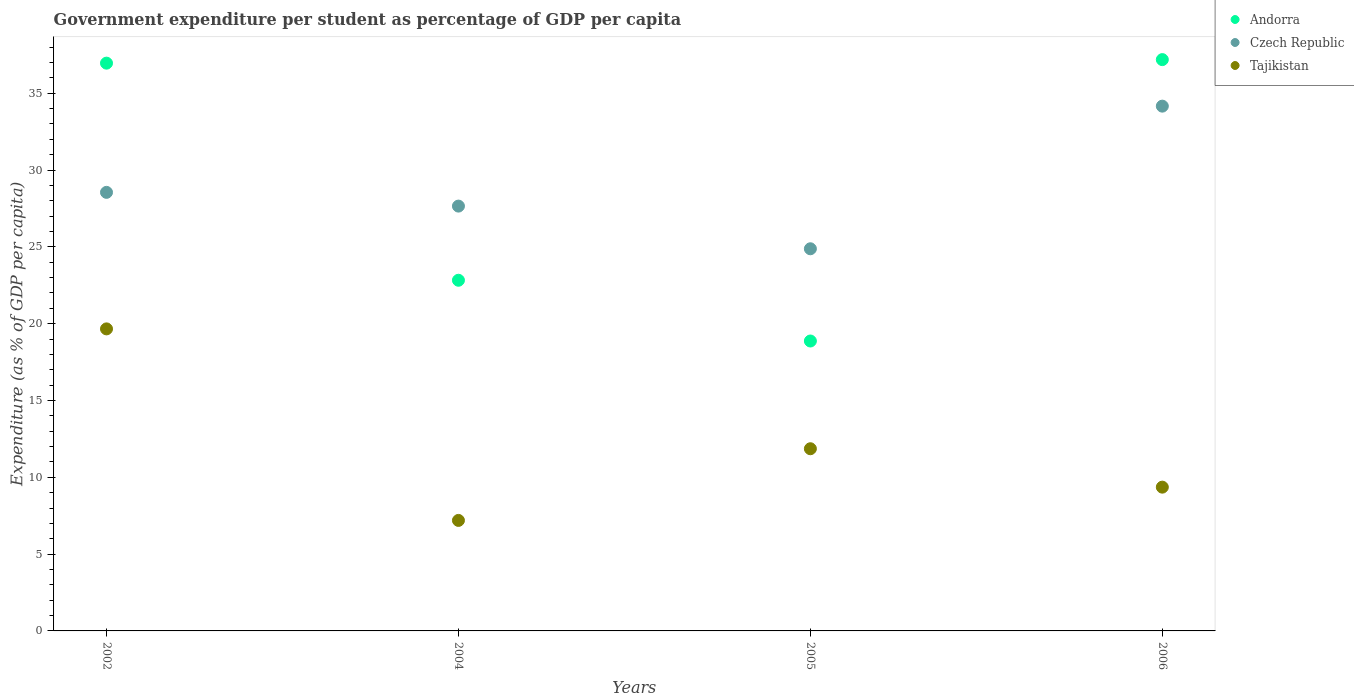How many different coloured dotlines are there?
Keep it short and to the point. 3. Is the number of dotlines equal to the number of legend labels?
Keep it short and to the point. Yes. What is the percentage of expenditure per student in Tajikistan in 2002?
Your answer should be compact. 19.66. Across all years, what is the maximum percentage of expenditure per student in Andorra?
Make the answer very short. 37.19. Across all years, what is the minimum percentage of expenditure per student in Andorra?
Your answer should be very brief. 18.87. In which year was the percentage of expenditure per student in Tajikistan maximum?
Offer a terse response. 2002. What is the total percentage of expenditure per student in Czech Republic in the graph?
Keep it short and to the point. 115.23. What is the difference between the percentage of expenditure per student in Czech Republic in 2002 and that in 2004?
Make the answer very short. 0.89. What is the difference between the percentage of expenditure per student in Czech Republic in 2006 and the percentage of expenditure per student in Andorra in 2005?
Ensure brevity in your answer.  15.29. What is the average percentage of expenditure per student in Czech Republic per year?
Provide a succinct answer. 28.81. In the year 2005, what is the difference between the percentage of expenditure per student in Andorra and percentage of expenditure per student in Tajikistan?
Offer a terse response. 7.01. What is the ratio of the percentage of expenditure per student in Tajikistan in 2004 to that in 2005?
Give a very brief answer. 0.61. What is the difference between the highest and the second highest percentage of expenditure per student in Czech Republic?
Offer a very short reply. 5.61. What is the difference between the highest and the lowest percentage of expenditure per student in Czech Republic?
Provide a succinct answer. 9.28. In how many years, is the percentage of expenditure per student in Andorra greater than the average percentage of expenditure per student in Andorra taken over all years?
Your answer should be compact. 2. Does the percentage of expenditure per student in Andorra monotonically increase over the years?
Your answer should be compact. No. How many dotlines are there?
Give a very brief answer. 3. What is the difference between two consecutive major ticks on the Y-axis?
Make the answer very short. 5. Where does the legend appear in the graph?
Offer a very short reply. Top right. How many legend labels are there?
Keep it short and to the point. 3. What is the title of the graph?
Give a very brief answer. Government expenditure per student as percentage of GDP per capita. Does "Estonia" appear as one of the legend labels in the graph?
Give a very brief answer. No. What is the label or title of the X-axis?
Your response must be concise. Years. What is the label or title of the Y-axis?
Give a very brief answer. Expenditure (as % of GDP per capita). What is the Expenditure (as % of GDP per capita) of Andorra in 2002?
Offer a terse response. 36.96. What is the Expenditure (as % of GDP per capita) in Czech Republic in 2002?
Provide a succinct answer. 28.55. What is the Expenditure (as % of GDP per capita) of Tajikistan in 2002?
Give a very brief answer. 19.66. What is the Expenditure (as % of GDP per capita) of Andorra in 2004?
Ensure brevity in your answer.  22.83. What is the Expenditure (as % of GDP per capita) in Czech Republic in 2004?
Keep it short and to the point. 27.65. What is the Expenditure (as % of GDP per capita) in Tajikistan in 2004?
Your answer should be very brief. 7.19. What is the Expenditure (as % of GDP per capita) of Andorra in 2005?
Give a very brief answer. 18.87. What is the Expenditure (as % of GDP per capita) in Czech Republic in 2005?
Offer a terse response. 24.87. What is the Expenditure (as % of GDP per capita) in Tajikistan in 2005?
Ensure brevity in your answer.  11.86. What is the Expenditure (as % of GDP per capita) in Andorra in 2006?
Ensure brevity in your answer.  37.19. What is the Expenditure (as % of GDP per capita) in Czech Republic in 2006?
Your response must be concise. 34.16. What is the Expenditure (as % of GDP per capita) of Tajikistan in 2006?
Your response must be concise. 9.36. Across all years, what is the maximum Expenditure (as % of GDP per capita) in Andorra?
Keep it short and to the point. 37.19. Across all years, what is the maximum Expenditure (as % of GDP per capita) in Czech Republic?
Provide a succinct answer. 34.16. Across all years, what is the maximum Expenditure (as % of GDP per capita) in Tajikistan?
Keep it short and to the point. 19.66. Across all years, what is the minimum Expenditure (as % of GDP per capita) in Andorra?
Your response must be concise. 18.87. Across all years, what is the minimum Expenditure (as % of GDP per capita) of Czech Republic?
Your response must be concise. 24.87. Across all years, what is the minimum Expenditure (as % of GDP per capita) in Tajikistan?
Provide a short and direct response. 7.19. What is the total Expenditure (as % of GDP per capita) in Andorra in the graph?
Make the answer very short. 115.84. What is the total Expenditure (as % of GDP per capita) of Czech Republic in the graph?
Ensure brevity in your answer.  115.23. What is the total Expenditure (as % of GDP per capita) of Tajikistan in the graph?
Keep it short and to the point. 48.07. What is the difference between the Expenditure (as % of GDP per capita) of Andorra in 2002 and that in 2004?
Give a very brief answer. 14.13. What is the difference between the Expenditure (as % of GDP per capita) in Czech Republic in 2002 and that in 2004?
Make the answer very short. 0.89. What is the difference between the Expenditure (as % of GDP per capita) of Tajikistan in 2002 and that in 2004?
Offer a terse response. 12.47. What is the difference between the Expenditure (as % of GDP per capita) in Andorra in 2002 and that in 2005?
Offer a terse response. 18.09. What is the difference between the Expenditure (as % of GDP per capita) in Czech Republic in 2002 and that in 2005?
Provide a short and direct response. 3.67. What is the difference between the Expenditure (as % of GDP per capita) in Tajikistan in 2002 and that in 2005?
Make the answer very short. 7.8. What is the difference between the Expenditure (as % of GDP per capita) in Andorra in 2002 and that in 2006?
Offer a very short reply. -0.23. What is the difference between the Expenditure (as % of GDP per capita) of Czech Republic in 2002 and that in 2006?
Offer a very short reply. -5.61. What is the difference between the Expenditure (as % of GDP per capita) in Tajikistan in 2002 and that in 2006?
Give a very brief answer. 10.3. What is the difference between the Expenditure (as % of GDP per capita) in Andorra in 2004 and that in 2005?
Your answer should be very brief. 3.95. What is the difference between the Expenditure (as % of GDP per capita) of Czech Republic in 2004 and that in 2005?
Keep it short and to the point. 2.78. What is the difference between the Expenditure (as % of GDP per capita) in Tajikistan in 2004 and that in 2005?
Offer a very short reply. -4.67. What is the difference between the Expenditure (as % of GDP per capita) in Andorra in 2004 and that in 2006?
Ensure brevity in your answer.  -14.36. What is the difference between the Expenditure (as % of GDP per capita) of Czech Republic in 2004 and that in 2006?
Your answer should be very brief. -6.51. What is the difference between the Expenditure (as % of GDP per capita) of Tajikistan in 2004 and that in 2006?
Your answer should be very brief. -2.17. What is the difference between the Expenditure (as % of GDP per capita) in Andorra in 2005 and that in 2006?
Offer a very short reply. -18.32. What is the difference between the Expenditure (as % of GDP per capita) in Czech Republic in 2005 and that in 2006?
Keep it short and to the point. -9.28. What is the difference between the Expenditure (as % of GDP per capita) of Tajikistan in 2005 and that in 2006?
Your response must be concise. 2.5. What is the difference between the Expenditure (as % of GDP per capita) in Andorra in 2002 and the Expenditure (as % of GDP per capita) in Czech Republic in 2004?
Your answer should be compact. 9.31. What is the difference between the Expenditure (as % of GDP per capita) of Andorra in 2002 and the Expenditure (as % of GDP per capita) of Tajikistan in 2004?
Provide a short and direct response. 29.76. What is the difference between the Expenditure (as % of GDP per capita) of Czech Republic in 2002 and the Expenditure (as % of GDP per capita) of Tajikistan in 2004?
Provide a succinct answer. 21.35. What is the difference between the Expenditure (as % of GDP per capita) in Andorra in 2002 and the Expenditure (as % of GDP per capita) in Czech Republic in 2005?
Offer a very short reply. 12.08. What is the difference between the Expenditure (as % of GDP per capita) in Andorra in 2002 and the Expenditure (as % of GDP per capita) in Tajikistan in 2005?
Offer a very short reply. 25.1. What is the difference between the Expenditure (as % of GDP per capita) of Czech Republic in 2002 and the Expenditure (as % of GDP per capita) of Tajikistan in 2005?
Offer a terse response. 16.69. What is the difference between the Expenditure (as % of GDP per capita) in Andorra in 2002 and the Expenditure (as % of GDP per capita) in Czech Republic in 2006?
Your answer should be compact. 2.8. What is the difference between the Expenditure (as % of GDP per capita) of Andorra in 2002 and the Expenditure (as % of GDP per capita) of Tajikistan in 2006?
Provide a short and direct response. 27.6. What is the difference between the Expenditure (as % of GDP per capita) in Czech Republic in 2002 and the Expenditure (as % of GDP per capita) in Tajikistan in 2006?
Offer a terse response. 19.19. What is the difference between the Expenditure (as % of GDP per capita) of Andorra in 2004 and the Expenditure (as % of GDP per capita) of Czech Republic in 2005?
Offer a terse response. -2.05. What is the difference between the Expenditure (as % of GDP per capita) of Andorra in 2004 and the Expenditure (as % of GDP per capita) of Tajikistan in 2005?
Ensure brevity in your answer.  10.97. What is the difference between the Expenditure (as % of GDP per capita) of Czech Republic in 2004 and the Expenditure (as % of GDP per capita) of Tajikistan in 2005?
Give a very brief answer. 15.79. What is the difference between the Expenditure (as % of GDP per capita) in Andorra in 2004 and the Expenditure (as % of GDP per capita) in Czech Republic in 2006?
Make the answer very short. -11.33. What is the difference between the Expenditure (as % of GDP per capita) of Andorra in 2004 and the Expenditure (as % of GDP per capita) of Tajikistan in 2006?
Offer a very short reply. 13.47. What is the difference between the Expenditure (as % of GDP per capita) of Czech Republic in 2004 and the Expenditure (as % of GDP per capita) of Tajikistan in 2006?
Give a very brief answer. 18.29. What is the difference between the Expenditure (as % of GDP per capita) in Andorra in 2005 and the Expenditure (as % of GDP per capita) in Czech Republic in 2006?
Provide a short and direct response. -15.29. What is the difference between the Expenditure (as % of GDP per capita) of Andorra in 2005 and the Expenditure (as % of GDP per capita) of Tajikistan in 2006?
Provide a short and direct response. 9.51. What is the difference between the Expenditure (as % of GDP per capita) of Czech Republic in 2005 and the Expenditure (as % of GDP per capita) of Tajikistan in 2006?
Ensure brevity in your answer.  15.52. What is the average Expenditure (as % of GDP per capita) in Andorra per year?
Keep it short and to the point. 28.96. What is the average Expenditure (as % of GDP per capita) in Czech Republic per year?
Ensure brevity in your answer.  28.81. What is the average Expenditure (as % of GDP per capita) of Tajikistan per year?
Give a very brief answer. 12.02. In the year 2002, what is the difference between the Expenditure (as % of GDP per capita) of Andorra and Expenditure (as % of GDP per capita) of Czech Republic?
Keep it short and to the point. 8.41. In the year 2002, what is the difference between the Expenditure (as % of GDP per capita) in Andorra and Expenditure (as % of GDP per capita) in Tajikistan?
Offer a very short reply. 17.3. In the year 2002, what is the difference between the Expenditure (as % of GDP per capita) of Czech Republic and Expenditure (as % of GDP per capita) of Tajikistan?
Offer a terse response. 8.89. In the year 2004, what is the difference between the Expenditure (as % of GDP per capita) in Andorra and Expenditure (as % of GDP per capita) in Czech Republic?
Offer a very short reply. -4.83. In the year 2004, what is the difference between the Expenditure (as % of GDP per capita) of Andorra and Expenditure (as % of GDP per capita) of Tajikistan?
Make the answer very short. 15.63. In the year 2004, what is the difference between the Expenditure (as % of GDP per capita) in Czech Republic and Expenditure (as % of GDP per capita) in Tajikistan?
Offer a very short reply. 20.46. In the year 2005, what is the difference between the Expenditure (as % of GDP per capita) in Andorra and Expenditure (as % of GDP per capita) in Czech Republic?
Offer a terse response. -6. In the year 2005, what is the difference between the Expenditure (as % of GDP per capita) in Andorra and Expenditure (as % of GDP per capita) in Tajikistan?
Your response must be concise. 7.01. In the year 2005, what is the difference between the Expenditure (as % of GDP per capita) of Czech Republic and Expenditure (as % of GDP per capita) of Tajikistan?
Provide a short and direct response. 13.02. In the year 2006, what is the difference between the Expenditure (as % of GDP per capita) of Andorra and Expenditure (as % of GDP per capita) of Czech Republic?
Ensure brevity in your answer.  3.03. In the year 2006, what is the difference between the Expenditure (as % of GDP per capita) in Andorra and Expenditure (as % of GDP per capita) in Tajikistan?
Give a very brief answer. 27.83. In the year 2006, what is the difference between the Expenditure (as % of GDP per capita) of Czech Republic and Expenditure (as % of GDP per capita) of Tajikistan?
Make the answer very short. 24.8. What is the ratio of the Expenditure (as % of GDP per capita) of Andorra in 2002 to that in 2004?
Your answer should be very brief. 1.62. What is the ratio of the Expenditure (as % of GDP per capita) of Czech Republic in 2002 to that in 2004?
Your answer should be very brief. 1.03. What is the ratio of the Expenditure (as % of GDP per capita) of Tajikistan in 2002 to that in 2004?
Provide a succinct answer. 2.73. What is the ratio of the Expenditure (as % of GDP per capita) of Andorra in 2002 to that in 2005?
Offer a terse response. 1.96. What is the ratio of the Expenditure (as % of GDP per capita) of Czech Republic in 2002 to that in 2005?
Ensure brevity in your answer.  1.15. What is the ratio of the Expenditure (as % of GDP per capita) in Tajikistan in 2002 to that in 2005?
Give a very brief answer. 1.66. What is the ratio of the Expenditure (as % of GDP per capita) of Czech Republic in 2002 to that in 2006?
Offer a very short reply. 0.84. What is the ratio of the Expenditure (as % of GDP per capita) of Tajikistan in 2002 to that in 2006?
Provide a short and direct response. 2.1. What is the ratio of the Expenditure (as % of GDP per capita) of Andorra in 2004 to that in 2005?
Ensure brevity in your answer.  1.21. What is the ratio of the Expenditure (as % of GDP per capita) of Czech Republic in 2004 to that in 2005?
Provide a succinct answer. 1.11. What is the ratio of the Expenditure (as % of GDP per capita) of Tajikistan in 2004 to that in 2005?
Your answer should be compact. 0.61. What is the ratio of the Expenditure (as % of GDP per capita) in Andorra in 2004 to that in 2006?
Offer a terse response. 0.61. What is the ratio of the Expenditure (as % of GDP per capita) of Czech Republic in 2004 to that in 2006?
Provide a short and direct response. 0.81. What is the ratio of the Expenditure (as % of GDP per capita) in Tajikistan in 2004 to that in 2006?
Your answer should be compact. 0.77. What is the ratio of the Expenditure (as % of GDP per capita) in Andorra in 2005 to that in 2006?
Ensure brevity in your answer.  0.51. What is the ratio of the Expenditure (as % of GDP per capita) in Czech Republic in 2005 to that in 2006?
Provide a succinct answer. 0.73. What is the ratio of the Expenditure (as % of GDP per capita) in Tajikistan in 2005 to that in 2006?
Your answer should be compact. 1.27. What is the difference between the highest and the second highest Expenditure (as % of GDP per capita) of Andorra?
Provide a succinct answer. 0.23. What is the difference between the highest and the second highest Expenditure (as % of GDP per capita) in Czech Republic?
Your response must be concise. 5.61. What is the difference between the highest and the second highest Expenditure (as % of GDP per capita) in Tajikistan?
Your answer should be compact. 7.8. What is the difference between the highest and the lowest Expenditure (as % of GDP per capita) of Andorra?
Give a very brief answer. 18.32. What is the difference between the highest and the lowest Expenditure (as % of GDP per capita) of Czech Republic?
Provide a short and direct response. 9.28. What is the difference between the highest and the lowest Expenditure (as % of GDP per capita) of Tajikistan?
Your response must be concise. 12.47. 